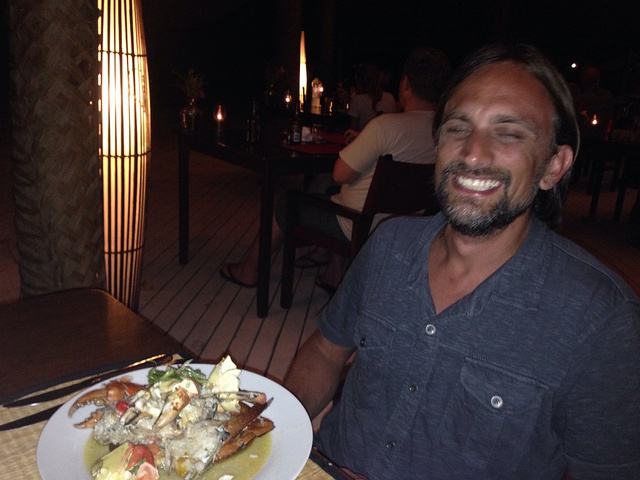Describe the objects in this image and their specific colors. I can see people in black, maroon, and brown tones, dining table in black, tan, darkgray, and lightgray tones, people in black, maroon, and brown tones, dining table in black, maroon, and brown tones, and chair in black, maroon, and brown tones in this image. 